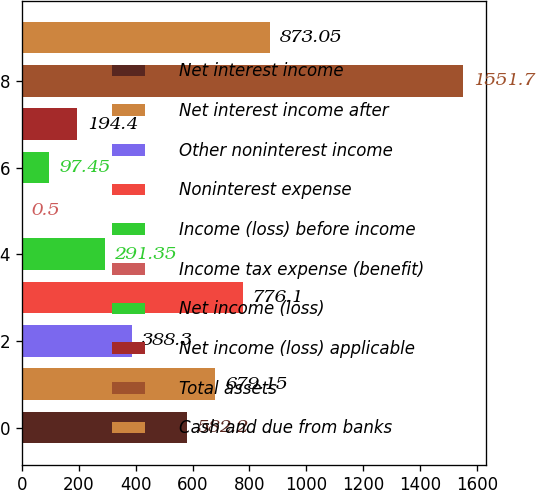Convert chart to OTSL. <chart><loc_0><loc_0><loc_500><loc_500><bar_chart><fcel>Net interest income<fcel>Net interest income after<fcel>Other noninterest income<fcel>Noninterest expense<fcel>Income (loss) before income<fcel>Income tax expense (benefit)<fcel>Net income (loss)<fcel>Net income (loss) applicable<fcel>Total assets<fcel>Cash and due from banks<nl><fcel>582.2<fcel>679.15<fcel>388.3<fcel>776.1<fcel>291.35<fcel>0.5<fcel>97.45<fcel>194.4<fcel>1551.7<fcel>873.05<nl></chart> 